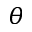<formula> <loc_0><loc_0><loc_500><loc_500>\theta</formula> 